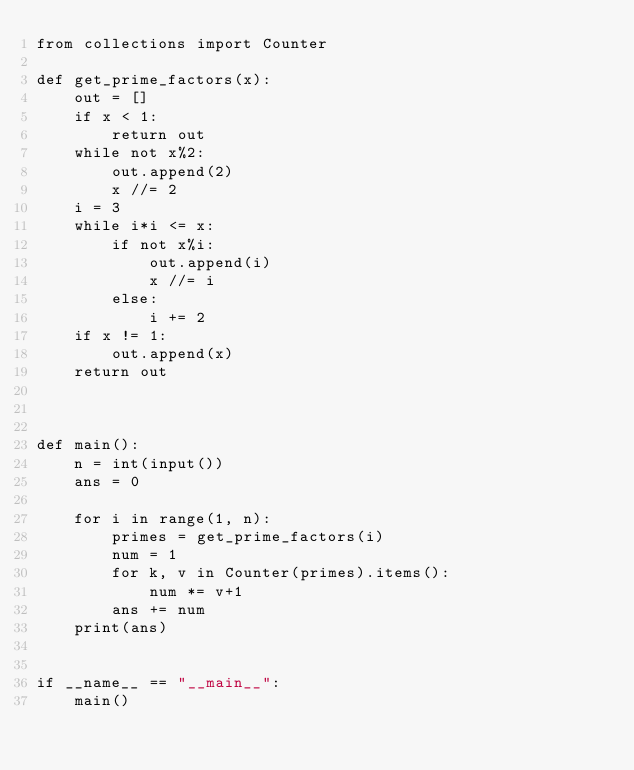Convert code to text. <code><loc_0><loc_0><loc_500><loc_500><_Python_>from collections import Counter

def get_prime_factors(x):
    out = []
    if x < 1:
        return out
    while not x%2:
        out.append(2)
        x //= 2
    i = 3
    while i*i <= x:
        if not x%i:
            out.append(i)
            x //= i
        else:
            i += 2
    if x != 1:
        out.append(x)
    return out



def main():
    n = int(input())
    ans = 0
    
    for i in range(1, n):
        primes = get_prime_factors(i)
        num = 1
        for k, v in Counter(primes).items():
            num *= v+1
        ans += num
    print(ans)
        

if __name__ == "__main__":
    main()</code> 